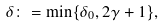Convert formula to latex. <formula><loc_0><loc_0><loc_500><loc_500>\delta \colon = \min \{ \delta _ { 0 } , 2 \gamma + 1 \} ,</formula> 